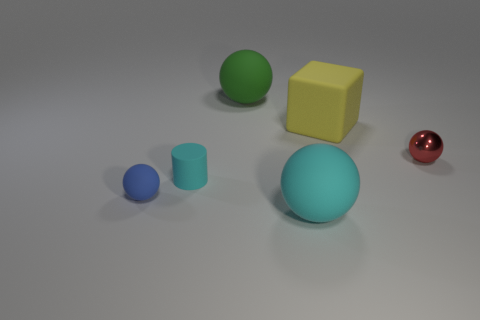Can you describe the lighting setup that might be used to create the shadows in this image? The lighting in the image seems to be coming from above, possibly from a single source, given the uniform direction of the shadows cast by the objects. The soft edges of the shadows suggest that the light source is not extremely close to the objects, allowing for a softer diffusion of light. 